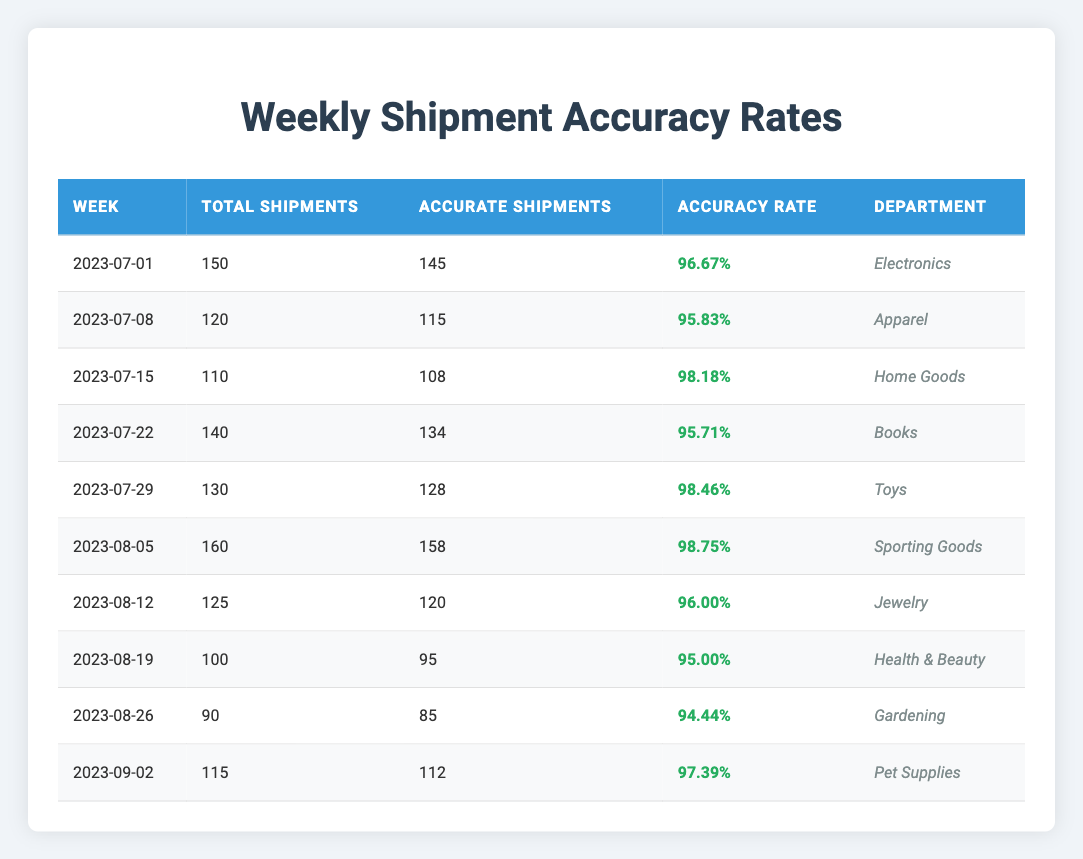What was the accuracy rate for the Electronics department? The table shows that for the week of July 1, 2023, the accuracy rate for the Electronics department was listed as 96.67%.
Answer: 96.67% Which week had the highest accuracy rate, and what was it? The highest accuracy rate is found in the week of August 5, 2023, where the accuracy rate was 98.75%.
Answer: 98.75% How many total shipments were made in the week of August 12, 2023? The table indicates that in the week of August 12, 2023, there were a total of 125 shipments.
Answer: 125 What is the average accuracy rate for all the weeks listed? To find the average accuracy rate, we add together all the accuracy rates (96.67 + 95.83 + 98.18 + 95.71 + 98.46 + 98.75 + 96.00 + 95.00 + 94.44 + 97.39 = 975.43) and divide by the number of weeks (10), which gives us an average of 97.54%.
Answer: 97.54% Did the Health & Beauty department have an accuracy rate above 95%? The Health & Beauty department had an accuracy rate of 95.00%, which is not above 95%. Thus, the answer is no.
Answer: No In which department did the lowest accuracy rate occur, and what was the rate? The lowest accuracy rate occurred in the Gardening department for the week of August 26, 2023, with a rate of 94.44%.
Answer: 94.44% Which week had the highest total shipments, and how many were there? The week with the highest total shipments was August 5, 2023, with a total of 160 shipments recorded.
Answer: 160 What is the difference between the total shipments of the week of July 15 and the week of July 29? The week of July 15 had 110 total shipments and the week of July 29 had 130. The difference is calculated by subtracting the two values (130 - 110 = 20).
Answer: 20 How many departments achieved an accuracy rate of 98% or higher? The departments that achieved an accuracy rate of 98% or higher are Home Goods, Toys, Sporting Goods, and the week of August 5. This totals to four departments.
Answer: 4 